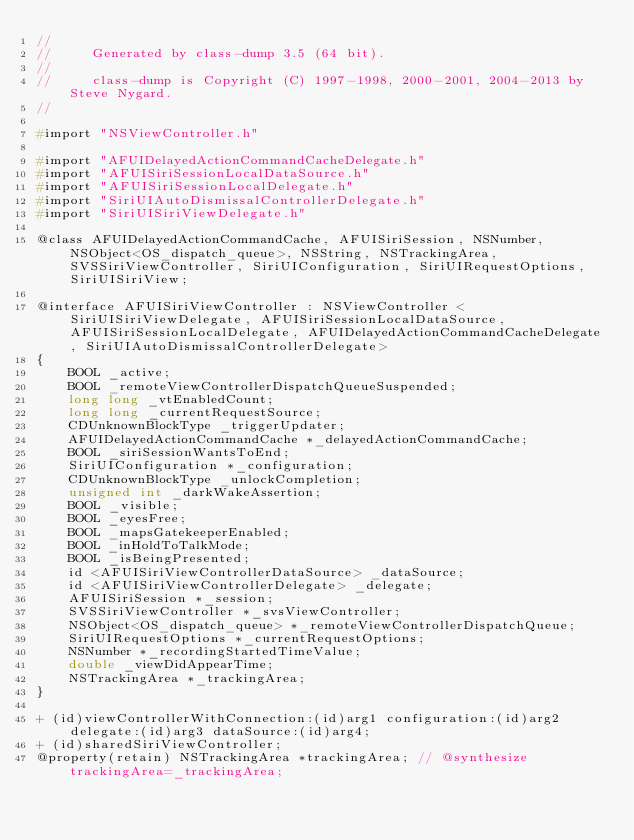Convert code to text. <code><loc_0><loc_0><loc_500><loc_500><_C_>//
//     Generated by class-dump 3.5 (64 bit).
//
//     class-dump is Copyright (C) 1997-1998, 2000-2001, 2004-2013 by Steve Nygard.
//

#import "NSViewController.h"

#import "AFUIDelayedActionCommandCacheDelegate.h"
#import "AFUISiriSessionLocalDataSource.h"
#import "AFUISiriSessionLocalDelegate.h"
#import "SiriUIAutoDismissalControllerDelegate.h"
#import "SiriUISiriViewDelegate.h"

@class AFUIDelayedActionCommandCache, AFUISiriSession, NSNumber, NSObject<OS_dispatch_queue>, NSString, NSTrackingArea, SVSSiriViewController, SiriUIConfiguration, SiriUIRequestOptions, SiriUISiriView;

@interface AFUISiriViewController : NSViewController <SiriUISiriViewDelegate, AFUISiriSessionLocalDataSource, AFUISiriSessionLocalDelegate, AFUIDelayedActionCommandCacheDelegate, SiriUIAutoDismissalControllerDelegate>
{
    BOOL _active;
    BOOL _remoteViewControllerDispatchQueueSuspended;
    long long _vtEnabledCount;
    long long _currentRequestSource;
    CDUnknownBlockType _triggerUpdater;
    AFUIDelayedActionCommandCache *_delayedActionCommandCache;
    BOOL _siriSessionWantsToEnd;
    SiriUIConfiguration *_configuration;
    CDUnknownBlockType _unlockCompletion;
    unsigned int _darkWakeAssertion;
    BOOL _visible;
    BOOL _eyesFree;
    BOOL _mapsGatekeeperEnabled;
    BOOL _inHoldToTalkMode;
    BOOL _isBeingPresented;
    id <AFUISiriViewControllerDataSource> _dataSource;
    id <AFUISiriViewControllerDelegate> _delegate;
    AFUISiriSession *_session;
    SVSSiriViewController *_svsViewController;
    NSObject<OS_dispatch_queue> *_remoteViewControllerDispatchQueue;
    SiriUIRequestOptions *_currentRequestOptions;
    NSNumber *_recordingStartedTimeValue;
    double _viewDidAppearTime;
    NSTrackingArea *_trackingArea;
}

+ (id)viewControllerWithConnection:(id)arg1 configuration:(id)arg2 delegate:(id)arg3 dataSource:(id)arg4;
+ (id)sharedSiriViewController;
@property(retain) NSTrackingArea *trackingArea; // @synthesize trackingArea=_trackingArea;</code> 